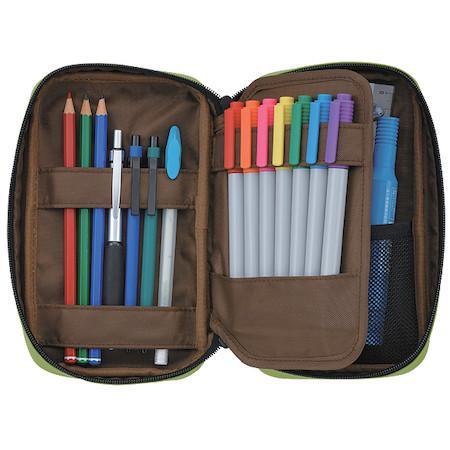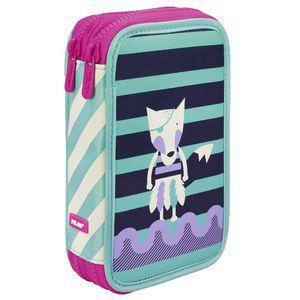The first image is the image on the left, the second image is the image on the right. Given the left and right images, does the statement "One container has a pair of scissors." hold true? Answer yes or no. No. The first image is the image on the left, the second image is the image on the right. For the images displayed, is the sentence "There is at least one pair of scissors inside of the binder in one of the images." factually correct? Answer yes or no. No. 